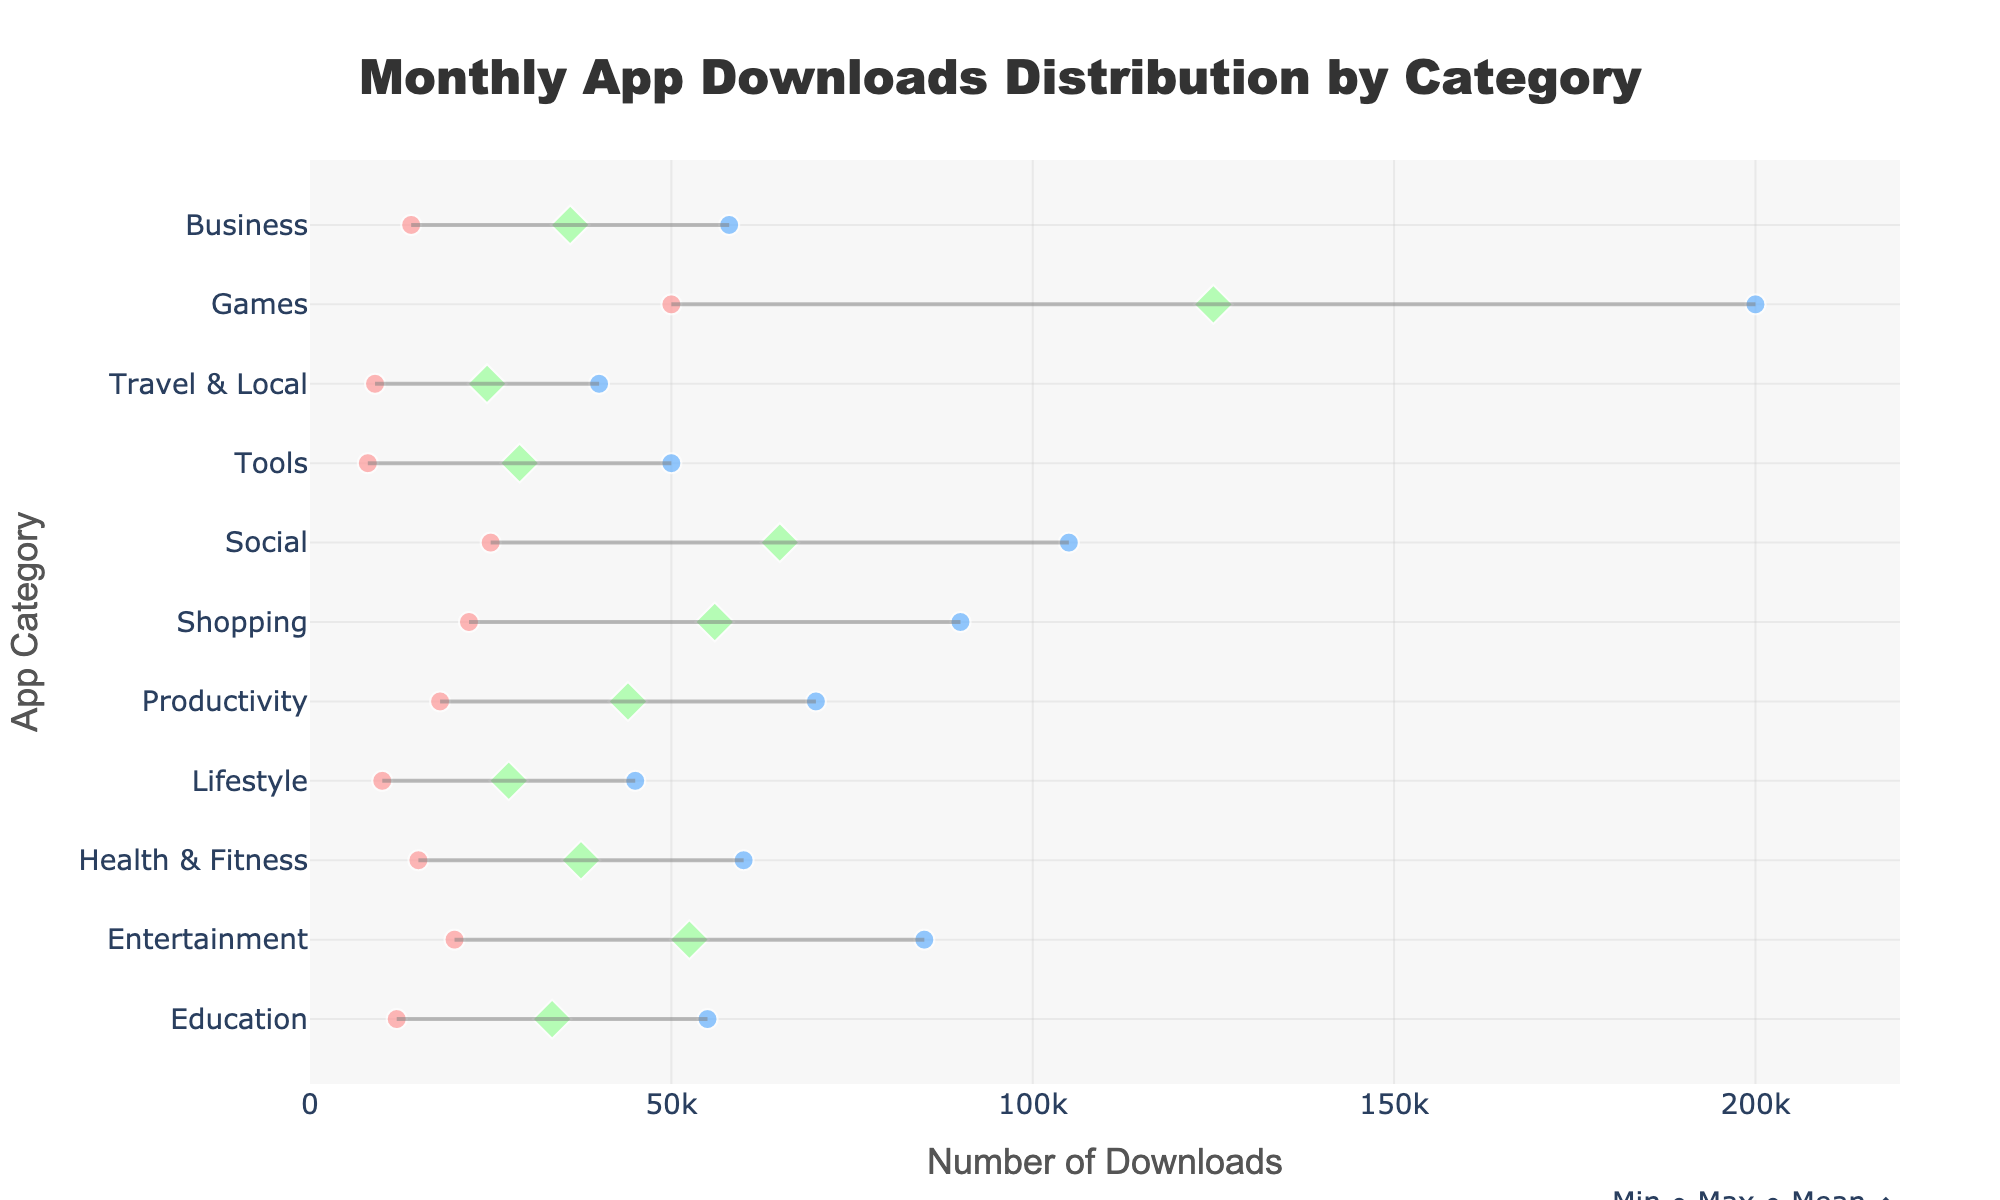What's the title of the plot? The plot's title is located at the top center. It reads "Monthly App Downloads Distribution by Category."
Answer: Monthly App Downloads Distribution by Category What does the plot's x-axis represent? The x-axis is labeled as "Number of Downloads," which indicates it represents the download counts.
Answer: Number of Downloads Which app category has the highest maximum downloads? Look at the x-coordinate of the maximum download values represented by the rightmost markers for each category. The furthest right marker belongs to "Games."
Answer: Games What is the range of downloads for the "Productivity" category? Check the positions of the leftmost (minimum) and rightmost (maximum) markers for the "Productivity" category. The minimum is 18,000 and the maximum is 70,000.
Answer: From 18,000 to 70,000 Which category has a mean download value closest to the midpoint of its range? For each app category, find the mean marker (diamond) and assess its position relative to the midpoint between the minimum and maximum markers. "Health & Fitness" has a mean (37,500) close to the midpoint of 37,500 between 15,000 and 60,000 downloads.
Answer: Health & Fitness How do the minimum downloads of "Travel & Local" compare to "Tools"? Compare the leftmost markers (min values) of "Travel & Local" and "Tools." "Travel & Local" has 9,000 while "Tools" has 8,000, so "Travel & Local" is higher.
Answer: Travel & Local is higher What is the difference between the highest and lowest mean downloads among all categories? Identify the highest mean (125,000 for "Games") and the lowest mean (24,500 for "Travel & Local") and calculate the difference: 125,000 - 24,500 = 100,500.
Answer: 100,500 Which app category has the smallest range of downloads? Calculate the range for each app category by subtracting the minimum download value from the maximum. "Travel & Local" ranges from 9,000 to 40,000, giving a range of 31,000, which is the smallest.
Answer: Travel & Local What is the average of the maximum download values for "Games" and "Entertainment"? The maximum for "Games" is 200,000 and for "Entertainment" is 85,000. Average these values: (200,000 + 85,000) / 2 = 142,500.
Answer: 142,500 Which categories have a mean download value higher than their respective maximum download minus 20,000? For each category, subtract 20,000 from the maximum value and check if the mean is higher. Categories fitting this condition are "Games" (mean 125,000, max 200,000 - 20,000 = 180,000), "Social" (mean 65,000, max 105,000 - 20,000 = 85,000), and "Shopping" (mean 56,000, max 90,000 - 20,000 = 70,000).
Answer: Games, Social, Shopping 